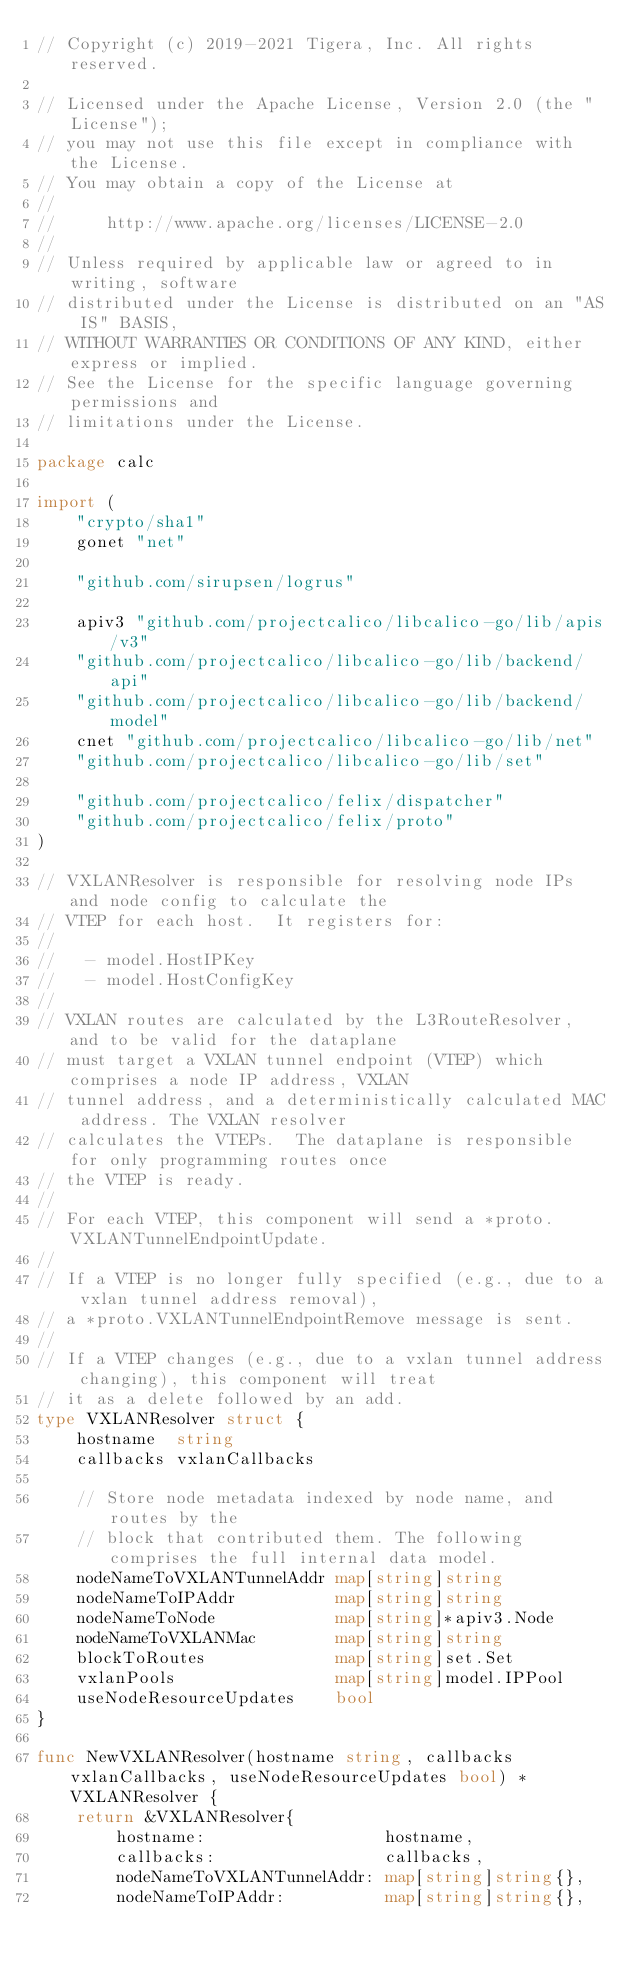<code> <loc_0><loc_0><loc_500><loc_500><_Go_>// Copyright (c) 2019-2021 Tigera, Inc. All rights reserved.

// Licensed under the Apache License, Version 2.0 (the "License");
// you may not use this file except in compliance with the License.
// You may obtain a copy of the License at
//
//     http://www.apache.org/licenses/LICENSE-2.0
//
// Unless required by applicable law or agreed to in writing, software
// distributed under the License is distributed on an "AS IS" BASIS,
// WITHOUT WARRANTIES OR CONDITIONS OF ANY KIND, either express or implied.
// See the License for the specific language governing permissions and
// limitations under the License.

package calc

import (
	"crypto/sha1"
	gonet "net"

	"github.com/sirupsen/logrus"

	apiv3 "github.com/projectcalico/libcalico-go/lib/apis/v3"
	"github.com/projectcalico/libcalico-go/lib/backend/api"
	"github.com/projectcalico/libcalico-go/lib/backend/model"
	cnet "github.com/projectcalico/libcalico-go/lib/net"
	"github.com/projectcalico/libcalico-go/lib/set"

	"github.com/projectcalico/felix/dispatcher"
	"github.com/projectcalico/felix/proto"
)

// VXLANResolver is responsible for resolving node IPs and node config to calculate the
// VTEP for each host.  It registers for:
//
//   - model.HostIPKey
//   - model.HostConfigKey
//
// VXLAN routes are calculated by the L3RouteResolver, and to be valid for the dataplane
// must target a VXLAN tunnel endpoint (VTEP) which comprises a node IP address, VXLAN
// tunnel address, and a deterministically calculated MAC address. The VXLAN resolver
// calculates the VTEPs.  The dataplane is responsible for only programming routes once
// the VTEP is ready.
//
// For each VTEP, this component will send a *proto.VXLANTunnelEndpointUpdate.
//
// If a VTEP is no longer fully specified (e.g., due to a vxlan tunnel address removal),
// a *proto.VXLANTunnelEndpointRemove message is sent.
//
// If a VTEP changes (e.g., due to a vxlan tunnel address changing), this component will treat
// it as a delete followed by an add.
type VXLANResolver struct {
	hostname  string
	callbacks vxlanCallbacks

	// Store node metadata indexed by node name, and routes by the
	// block that contributed them. The following comprises the full internal data model.
	nodeNameToVXLANTunnelAddr map[string]string
	nodeNameToIPAddr          map[string]string
	nodeNameToNode            map[string]*apiv3.Node
	nodeNameToVXLANMac        map[string]string
	blockToRoutes             map[string]set.Set
	vxlanPools                map[string]model.IPPool
	useNodeResourceUpdates    bool
}

func NewVXLANResolver(hostname string, callbacks vxlanCallbacks, useNodeResourceUpdates bool) *VXLANResolver {
	return &VXLANResolver{
		hostname:                  hostname,
		callbacks:                 callbacks,
		nodeNameToVXLANTunnelAddr: map[string]string{},
		nodeNameToIPAddr:          map[string]string{},</code> 